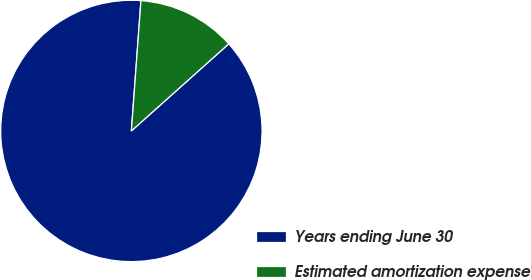<chart> <loc_0><loc_0><loc_500><loc_500><pie_chart><fcel>Years ending June 30<fcel>Estimated amortization expense<nl><fcel>87.78%<fcel>12.22%<nl></chart> 